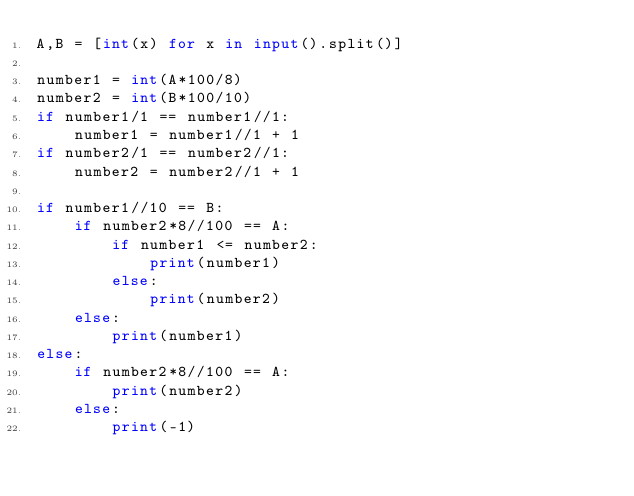Convert code to text. <code><loc_0><loc_0><loc_500><loc_500><_Python_>A,B = [int(x) for x in input().split()]

number1 = int(A*100/8)
number2 = int(B*100/10)
if number1/1 == number1//1:
    number1 = number1//1 + 1
if number2/1 == number2//1:
    number2 = number2//1 + 1

if number1//10 == B:
    if number2*8//100 == A:
        if number1 <= number2:
            print(number1)
        else:
            print(number2)
    else:
        print(number1)
else:
    if number2*8//100 == A:
        print(number2)
    else:
        print(-1)</code> 